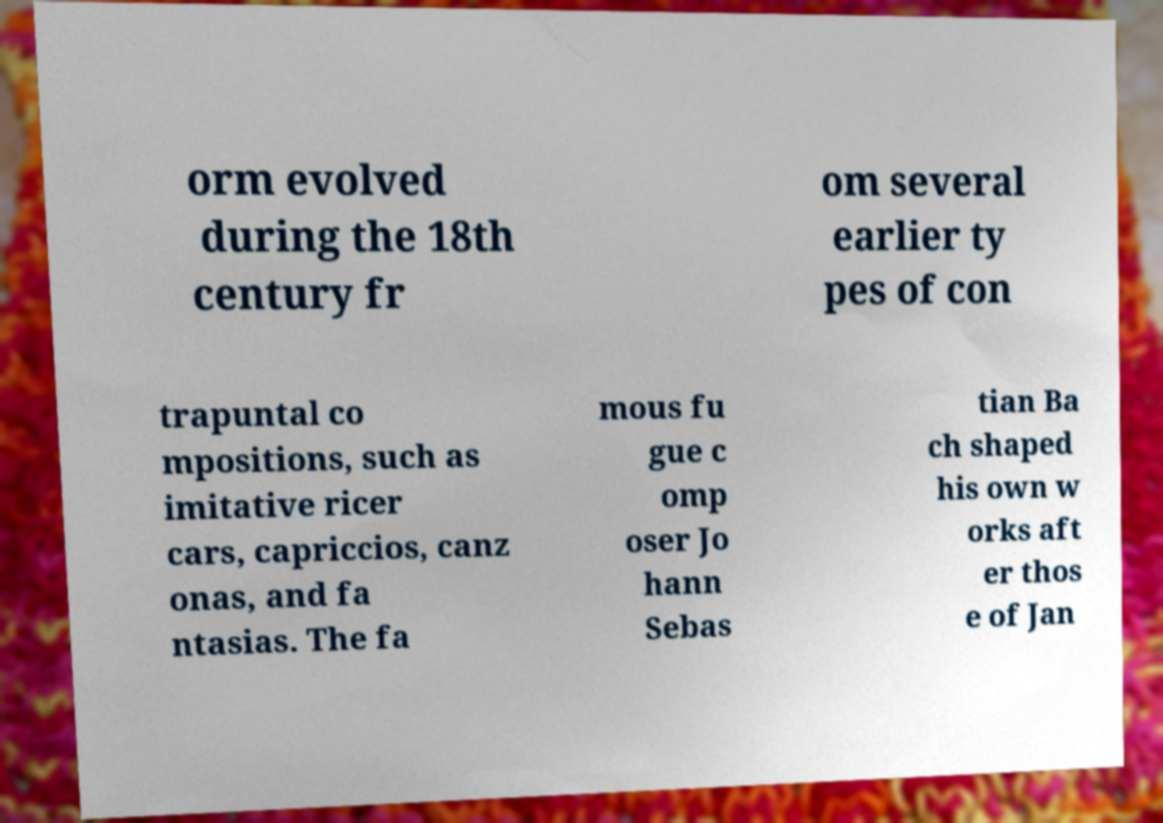Can you accurately transcribe the text from the provided image for me? orm evolved during the 18th century fr om several earlier ty pes of con trapuntal co mpositions, such as imitative ricer cars, capriccios, canz onas, and fa ntasias. The fa mous fu gue c omp oser Jo hann Sebas tian Ba ch shaped his own w orks aft er thos e of Jan 